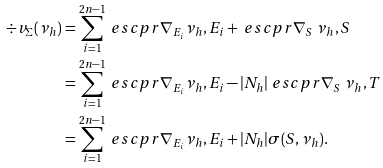<formula> <loc_0><loc_0><loc_500><loc_500>\div v _ { \Sigma } ( \nu _ { h } ) & = \sum _ { i = 1 } ^ { 2 n - 1 } \ e s c p r { \nabla _ { E _ { i } } \nu _ { h } , E _ { i } } + \ e s c p r { \nabla _ { S } \ \nu _ { h } , S } \\ & = \sum _ { i = 1 } ^ { 2 n - 1 } \ e s c p r { \nabla _ { E _ { i } } \nu _ { h } , E _ { i } } - | N _ { h } | \ e s c p r { \nabla _ { S } \ \nu _ { h } , T } \\ & = \sum _ { i = 1 } ^ { 2 n - 1 } \ e s c p r { \nabla _ { E _ { i } } \nu _ { h } , E _ { i } } + | N _ { h } | \sigma ( S , \nu _ { h } ) .</formula> 